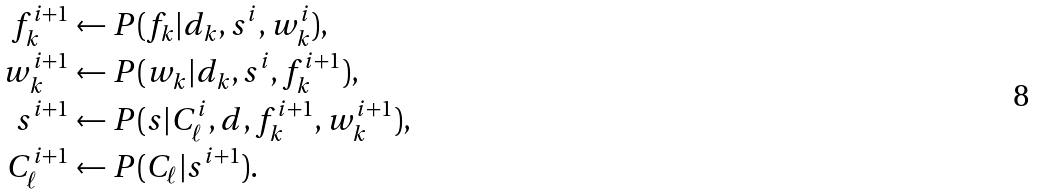Convert formula to latex. <formula><loc_0><loc_0><loc_500><loc_500>f _ { k } ^ { i + 1 } & \leftarrow P ( f _ { k } | d _ { k } , s ^ { i } , w _ { k } ^ { i } ) , \\ w _ { k } ^ { i + 1 } & \leftarrow P ( w _ { k } | d _ { k } , s ^ { i } , f _ { k } ^ { i + 1 } ) , \\ s ^ { i + 1 } & \leftarrow P ( s | C _ { \ell } ^ { i } , d , f _ { k } ^ { i + 1 } , w _ { k } ^ { i + 1 } ) , \\ C _ { \ell } ^ { i + 1 } & \leftarrow P ( C _ { \ell } | s ^ { i + 1 } ) .</formula> 